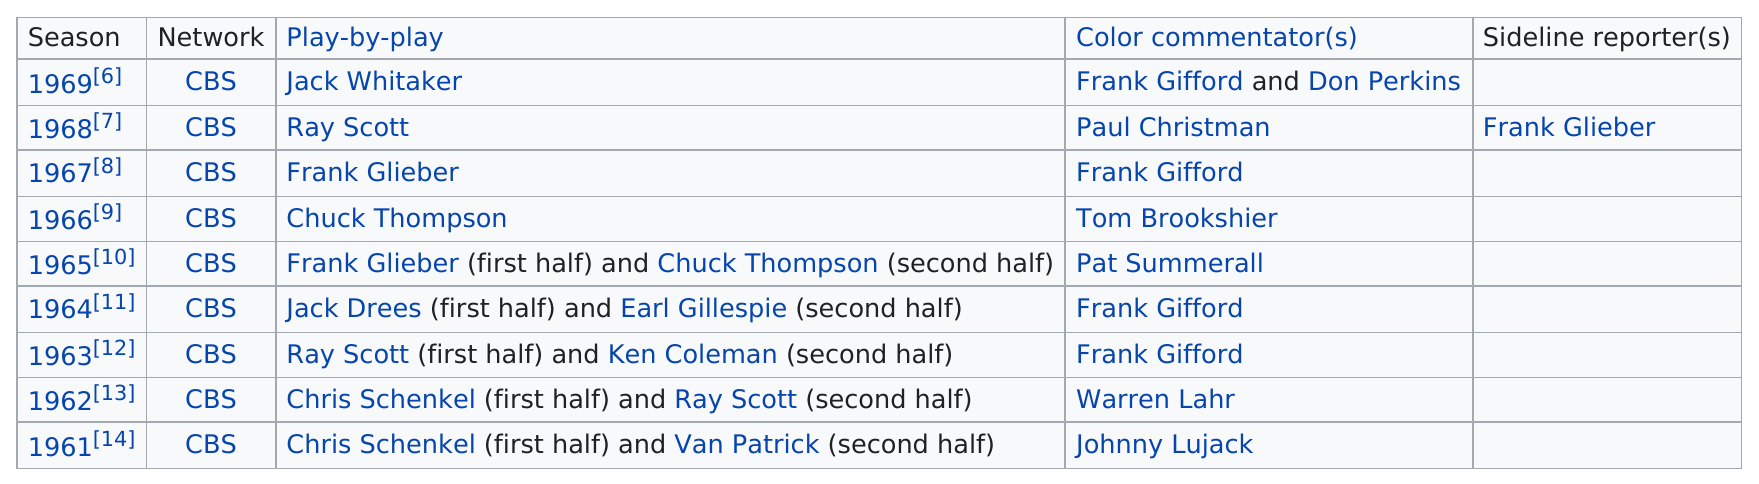Give some essential details in this illustration. The Detroit Lions made a total of three appearances. Before Ray Scott, Jack Whitaker played play-by-play, During the playoff bowl era, the Baltimore Colts won two games. Chris Schenkel had two consecutive performances as the first half play-by-play broadcaster. The last season of CBS's play-by-play was in 1969. 